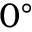Convert formula to latex. <formula><loc_0><loc_0><loc_500><loc_500>0 ^ { \circ }</formula> 